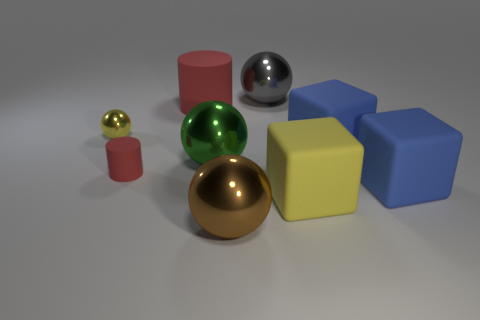There is a thing that is in front of the yellow matte block; what is it made of?
Provide a short and direct response. Metal. The rubber thing that is the same color as the tiny matte cylinder is what size?
Your answer should be very brief. Large. How many objects are either cubes behind the tiny red cylinder or large gray matte cubes?
Offer a terse response. 1. Is the number of large green metallic things that are right of the big red cylinder the same as the number of green metallic cubes?
Keep it short and to the point. No. Is the brown object the same size as the yellow metallic sphere?
Your answer should be very brief. No. What color is the matte cylinder that is the same size as the yellow matte block?
Provide a succinct answer. Red. Does the yellow matte thing have the same size as the gray sphere to the right of the small yellow metallic object?
Offer a very short reply. Yes. How many tiny rubber objects have the same color as the big rubber cylinder?
Your answer should be very brief. 1. How many objects are either big matte cylinders or big things behind the brown object?
Provide a short and direct response. 6. Does the matte thing behind the yellow ball have the same size as the sphere on the left side of the small red matte object?
Give a very brief answer. No. 